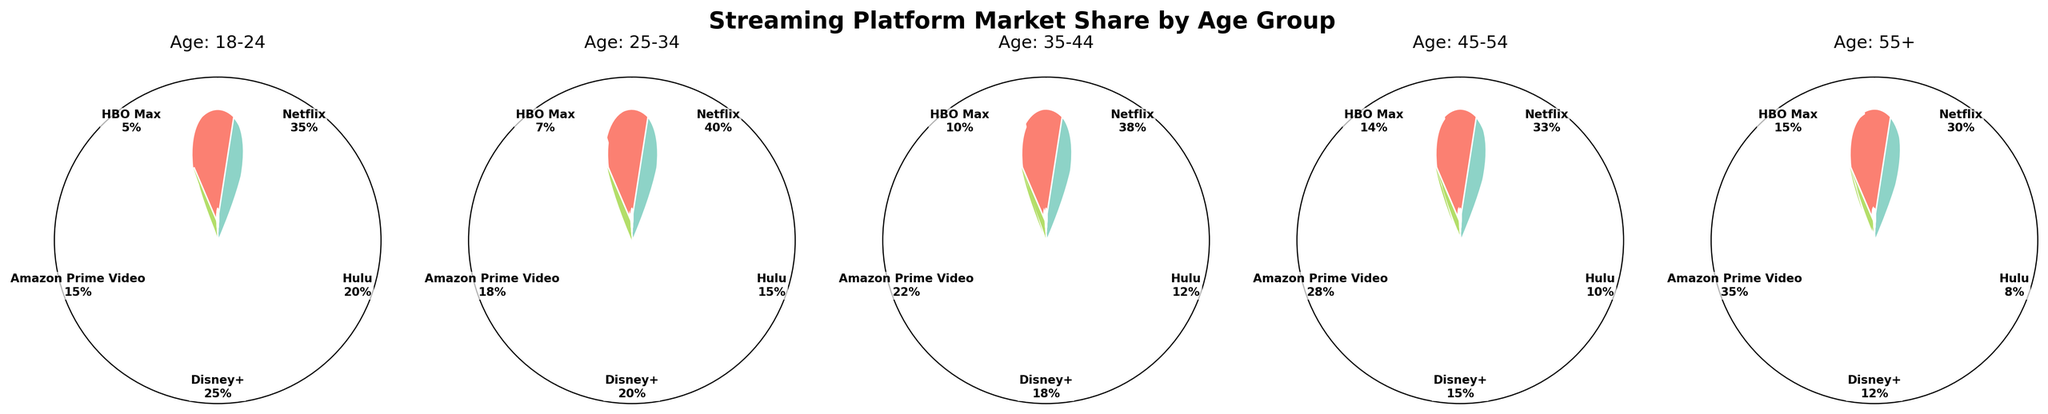What's the title of the figure? The title of the figure is prominently displayed at the top of the charts and reads "Streaming Platform Market Share by Age Group".
Answer: Streaming Platform Market Share by Age Group What's the market share of Netflix for the 18-24 age group? By looking at the gauge chart labeled "Age: 18-24," we can see that the gauge for Netflix is filled to 35%, indicating a market share of 0.35 or 35%.
Answer: 35% Which streaming platform has the highest market share among the 25-34 age group? Under the "Age: 25-34" gauge chart, Netflix has the largest filled segment at 40%, indicating the highest market share in this age group.
Answer: Netflix How does the market share of Amazon Prime Video in the 35-44 age group compare to that in the 45-54 age group? In the "Age: 35-44" gauge chart, Amazon Prime Video has a market share of 22%. In the "Age: 45-54" gauge chart, its market share is 28%. Thus, it is higher for the 45-54 age group.
Answer: Amazon Prime Video has a higher market share in the 45-54 age group What is the average market share of Disney+ across all age groups? The market shares of Disney+ across the age groups are 25%, 20%, 18%, 15%, and 12%. Adding these up gives 90%, and dividing by the 5 age groups gives an average of 18%.
Answer: 18% Which streaming platform has the least variation in market share across all age groups? To find the variation, we check the fluctuation in market share percentages for each platform. Hulu's shares are 20%, 15%, 12%, 10%, and 8%. The variation appears to be minimal compared to others.
Answer: Hulu Is the market share of Disney+ higher or lower than Hulu across the 18-24 and 25-34 age groups? In the 18-24 age group, Disney+ (25%) is higher than Hulu (20%). In the 25-34 age group, Disney+ (20%) is again higher than Hulu (15%).
Answer: Higher How does the market share of HBO Max change from the 18-24 age group to the 55+ age group? In the 18-24 age group, HBO Max has a market share of 5%. In the 55+ age group, it has a market share of 15%. This indicates an increase as the age group changes.
Answer: It increases What is the combined market share of Netflix and Amazon Prime Video in the 35-44 age group? For the 35-44 age group, combining Netflix's 38% and Amazon Prime Video's 22% results in a total of 60%.
Answer: 60% 